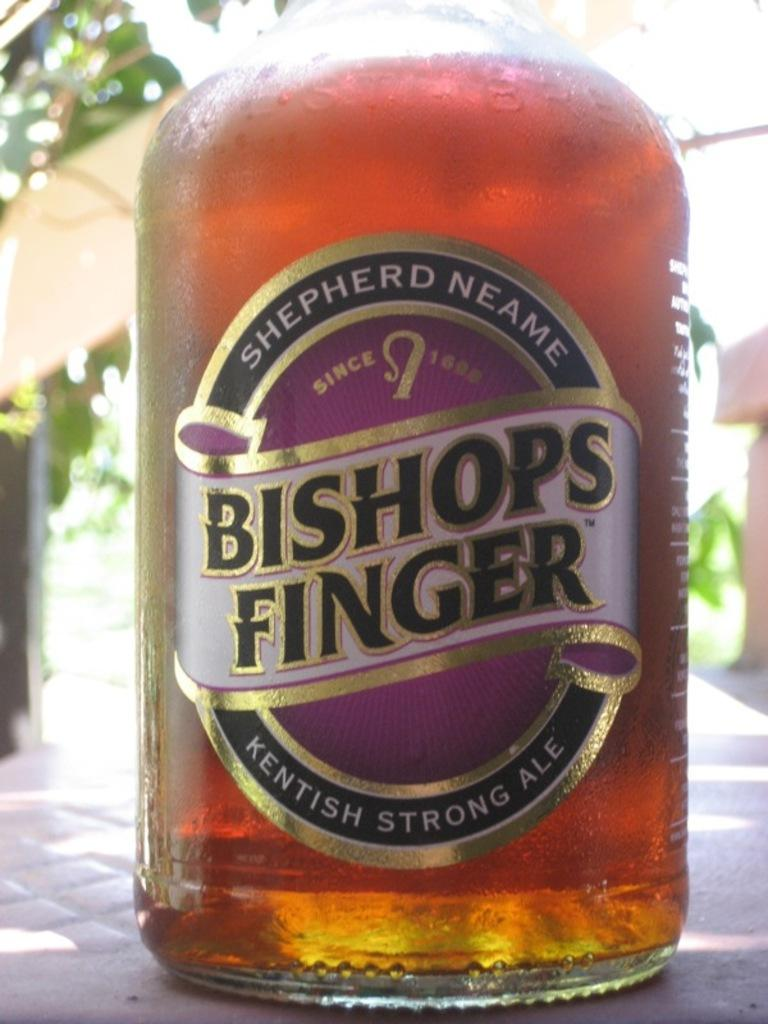<image>
Provide a brief description of the given image. The bottom portion of a bottle of Bishops FInger ale. 